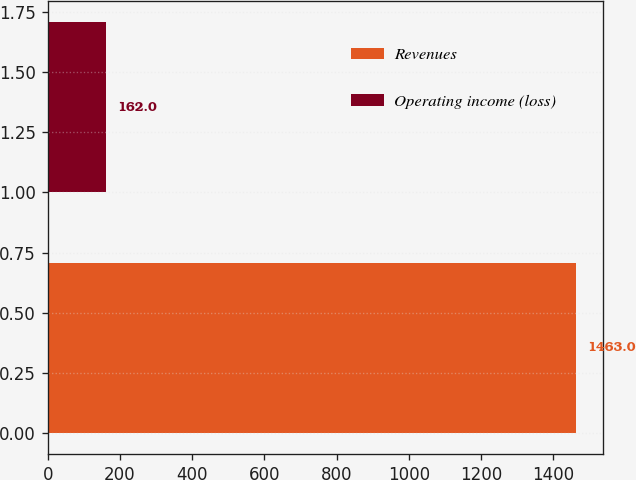Convert chart to OTSL. <chart><loc_0><loc_0><loc_500><loc_500><bar_chart><fcel>Revenues<fcel>Operating income (loss)<nl><fcel>1463<fcel>162<nl></chart> 